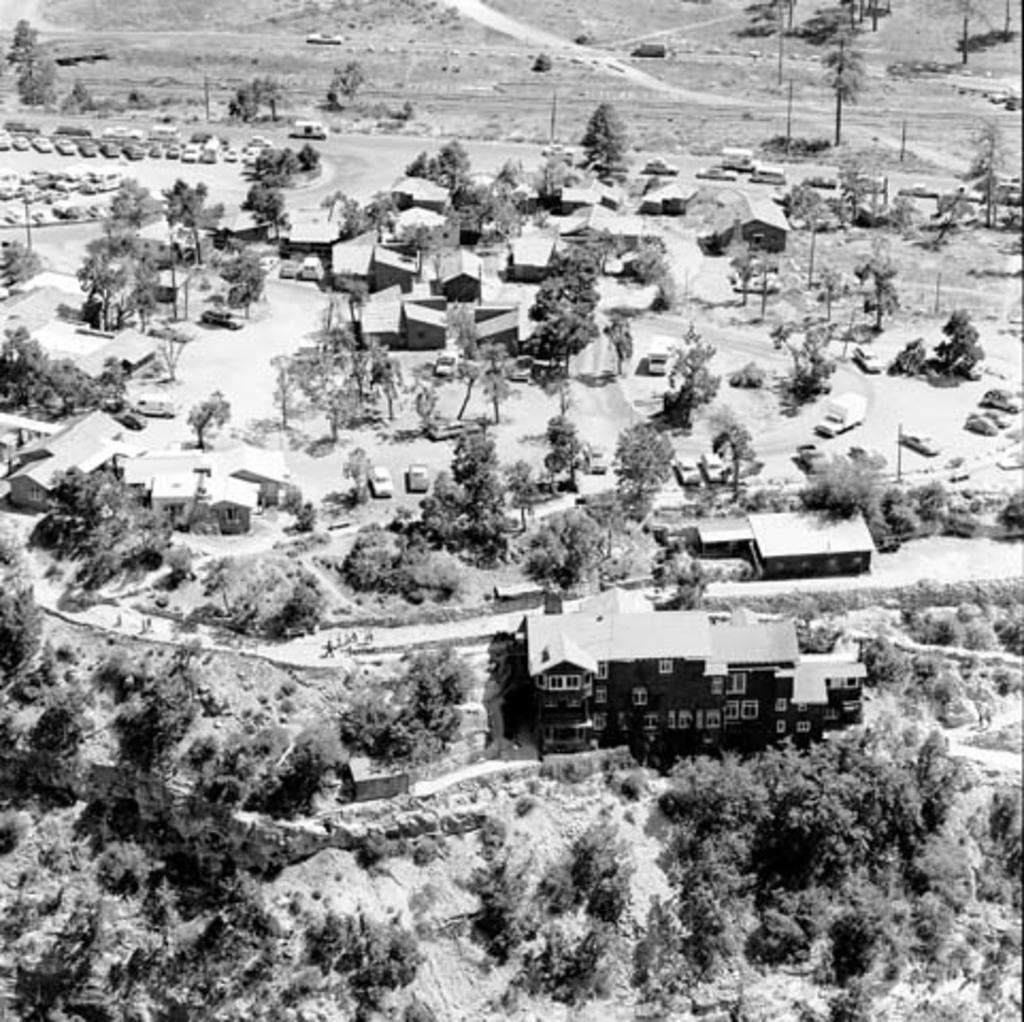Can you describe this image briefly? Here in this picture we can see an aerial view, from which we can see number of houses and buildings present on the ground and we can also see plants and trees present and we can see some part of ground is covered with grass and we can also see number of cars present. 